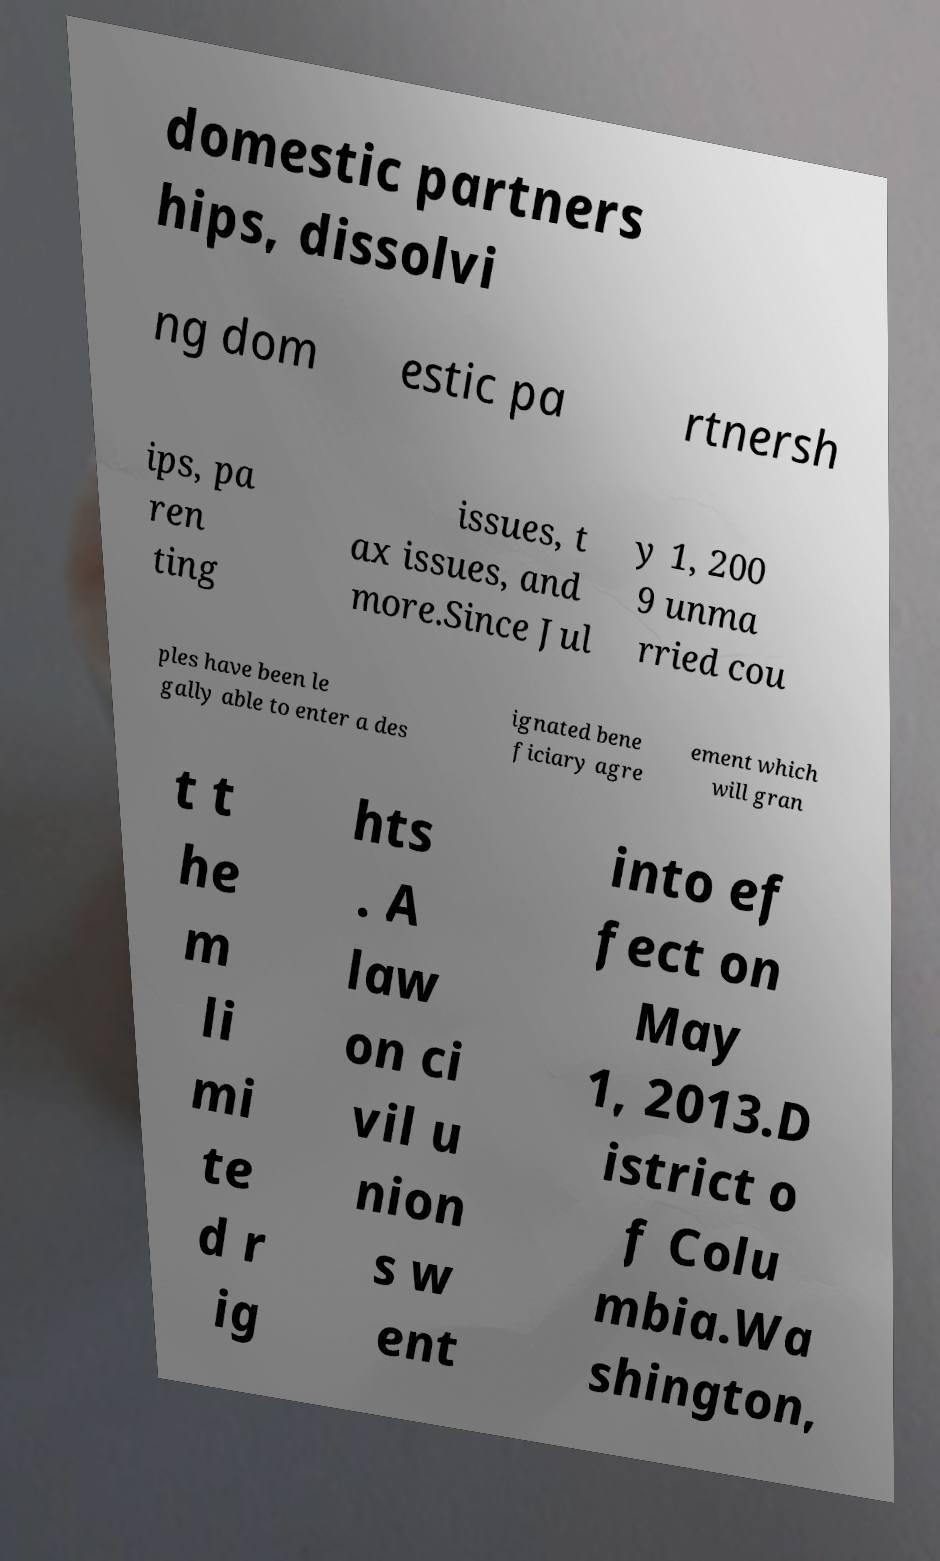I need the written content from this picture converted into text. Can you do that? domestic partners hips, dissolvi ng dom estic pa rtnersh ips, pa ren ting issues, t ax issues, and more.Since Jul y 1, 200 9 unma rried cou ples have been le gally able to enter a des ignated bene ficiary agre ement which will gran t t he m li mi te d r ig hts . A law on ci vil u nion s w ent into ef fect on May 1, 2013.D istrict o f Colu mbia.Wa shington, 